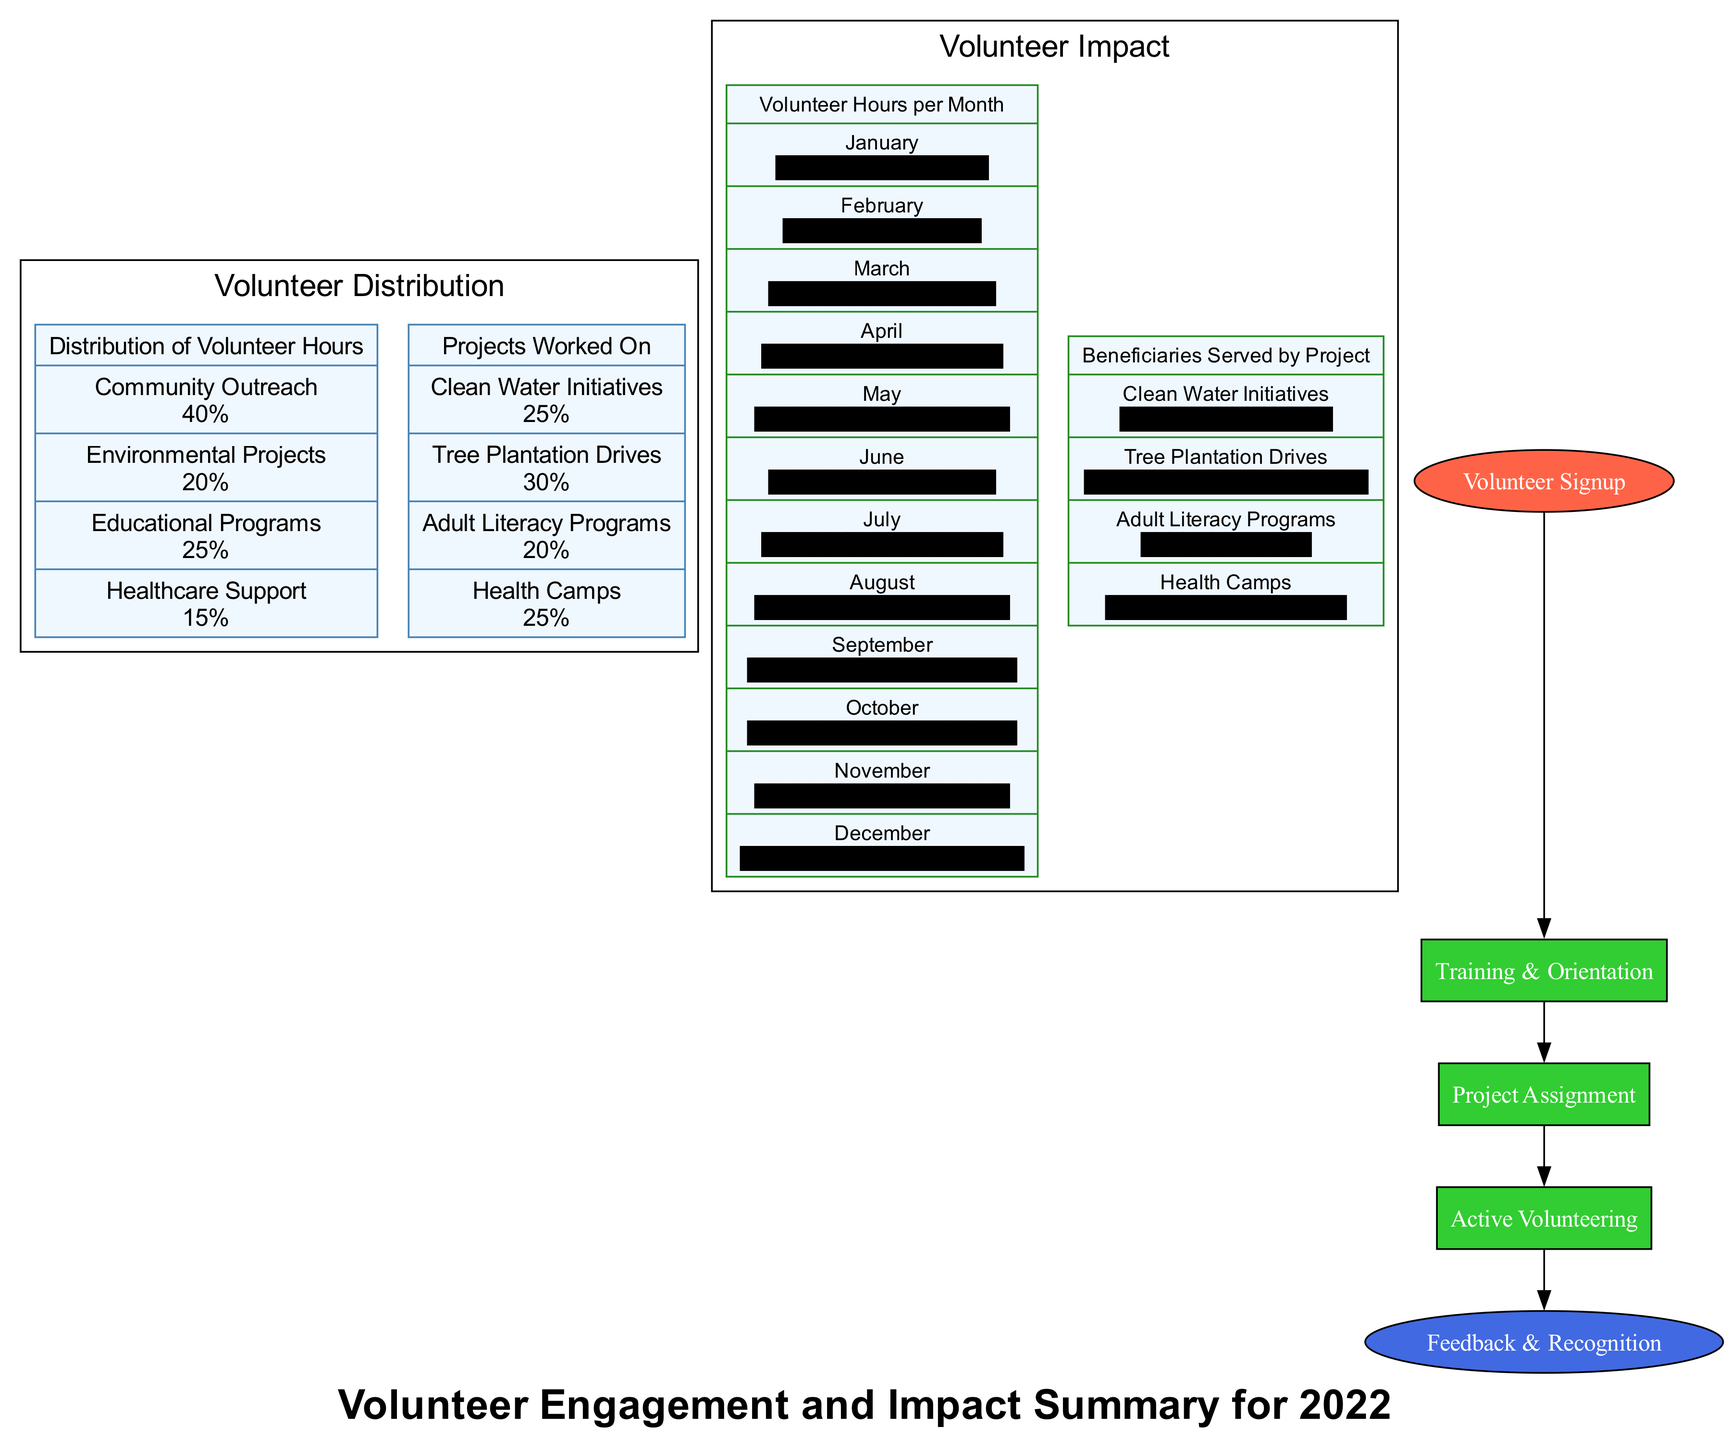What is the total percentage of volunteer hours dedicated to Community Outreach and Educational Programs? The percentage for Community Outreach is 40% and for Educational Programs is 25%. Adding these together gives 40% + 25% = 65%.
Answer: 65% Which project had the highest number of beneficiaries served? The project with the highest beneficiaries served is the Tree Plantation Drives at 2000.
Answer: 2000 How many months showed an increase in volunteer hours compared to the previous month? By analyzing the bar graph, we see that from January to February there was a decrease, but from February to March (increased), March to April (increased), April to May (increased), and from June to July (increased), resulting in a total of five months.
Answer: 5 What is the last step in the Volunteer Journey? The last step is "Feedback & Recognition".
Answer: Feedback & Recognition Which segment of the "Distribution of Volunteer Hours" has the least amount of hours dedicated? The segment with the least amount of hours is "Healthcare Support" at 15%.
Answer: Healthcare Support What is the value of volunteer hours in December? According to the bar graph, the value of volunteer hours in December is 510.
Answer: 510 In the "Projects Worked On" pie chart, what is the percentage allocated to Adult Literacy Programs? The percentage allocated to Adult Literacy Programs is 20%.
Answer: 20% How many processes are included from "Volunteer Signup" to "Feedback & Recognition" in the flow diagram? There are three processes: Training & Orientation, Project Assignment, and Active Volunteering, making a total of four nodes minus the start and end node.
Answer: 3 